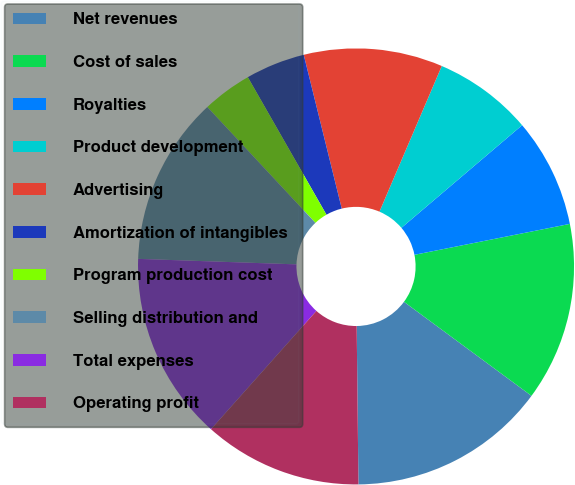Convert chart to OTSL. <chart><loc_0><loc_0><loc_500><loc_500><pie_chart><fcel>Net revenues<fcel>Cost of sales<fcel>Royalties<fcel>Product development<fcel>Advertising<fcel>Amortization of intangibles<fcel>Program production cost<fcel>Selling distribution and<fcel>Total expenses<fcel>Operating profit<nl><fcel>14.71%<fcel>13.24%<fcel>8.09%<fcel>7.35%<fcel>10.29%<fcel>4.41%<fcel>3.68%<fcel>12.5%<fcel>13.97%<fcel>11.76%<nl></chart> 